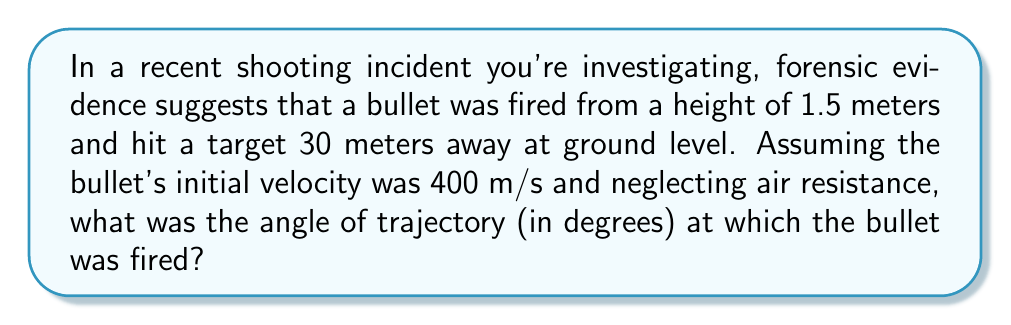Can you solve this math problem? To solve this problem, we'll use the equations of projectile motion. Let's break it down step-by-step:

1) First, we need to identify the known variables:
   - Initial height (h) = 1.5 m
   - Horizontal distance (d) = 30 m
   - Initial velocity (v) = 400 m/s
   - Vertical displacement (y) = -1.5 m (from initial height to ground)
   - Acceleration due to gravity (g) = 9.8 m/s²

2) We're looking for the angle of trajectory (θ). We can use the equation:

   $$y = x \tan θ - \frac{gx^2}{2v^2\cos^2θ}$$

   Where x is the horizontal distance.

3) Substituting our known values:

   $$-1.5 = 30 \tan θ - \frac{9.8 \cdot 30^2}{2 \cdot 400^2\cos^2θ}$$

4) Simplify:

   $$-1.5 = 30 \tan θ - \frac{8820}{320000\cos^2θ}$$

5) This equation is complex to solve algebraically, so we'll use a numerical method. By trial and error or using a graphing calculator, we find that θ ≈ 0.0183 radians.

6) Convert radians to degrees:

   $$θ \approx 0.0183 \cdot \frac{180}{\pi} \approx 1.05°$$
Answer: $1.05°$ 